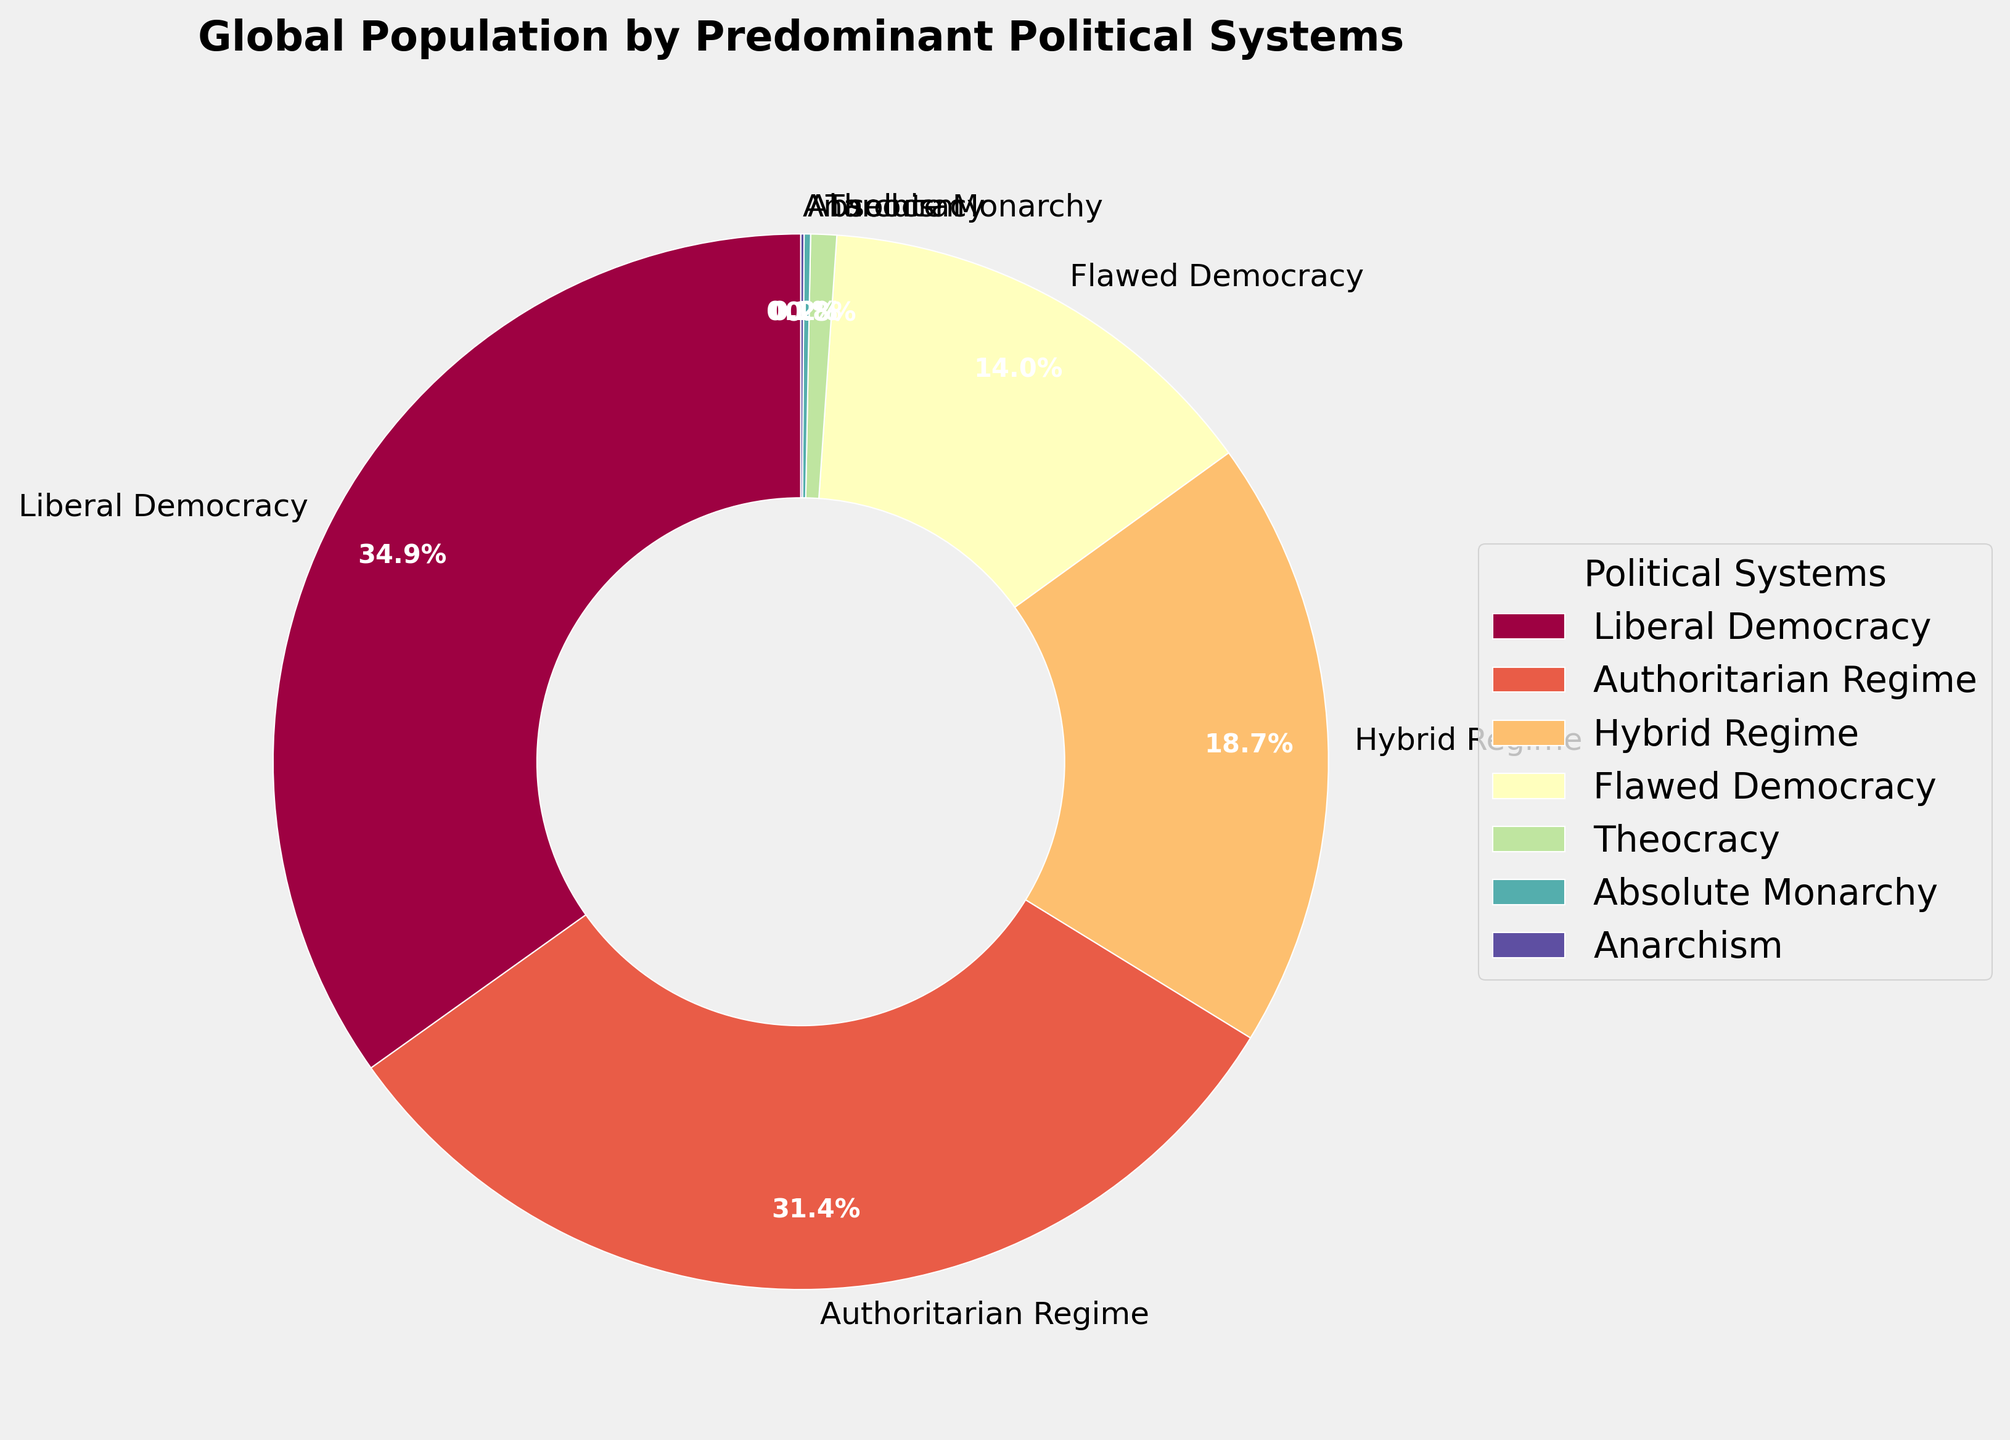Which political system has the largest share of the global population? The largest section of the pie chart will correspond to the political system with the highest population percentage. By checking the segments, we can identify the largest one. Liberal Democracy has the largest share.
Answer: Liberal Democracy What is the combined population percentage of Liberal Democracy and Authoritarian Regime? To find the combined population percentage, add the percentages of Liberal Democracy and Authoritarian Regime. Liberal Democracy is 35.2% and Authoritarian Regime is 31.7%. Sum these values: 35.2 + 31.7 = 66.9.
Answer: 66.9% Which political system has the smallest share of the global population? The smallest section of the pie chart will correspond to the political system with the lowest population percentage. By checking the segments, we can identify the smallest one. Anarchism has the smallest share.
Answer: Anarchism How much higher is the population percentage of Authoritarian Regime compared to Flawed Democracy? We can find the difference by subtracting the percentage of Flawed Democracy from the percentage of Authoritarian Regime. Authoritarian Regime is 31.7%, and Flawed Democracy is 14.1%. The difference is 31.7 - 14.1 = 17.6.
Answer: 17.6% What are the three political systems with the highest population percentages? By ranking the segments of the pie chart from highest to lowest, we can identify the top three. Liberal Democracy, Authoritarian Regime, and Hybrid Regime have the highest shares, respectively.
Answer: Liberal Democracy, Authoritarian Regime, Hybrid Regime What is the total population percentage represented by political systems other than Liberal Democracy? Subtract the percentage of Liberal Democracy from 100%. Liberal Democracy is 35.2%, so 100 - 35.2 = 64.8.
Answer: 64.8% Are there more people living under Authoritarian Regimes or Hybrid Regimes? By comparing the pie chart segments for Authoritarian Regime and Hybrid Regime, we can determine that Authoritarian Regime has a larger share than Hybrid Regime. Authoritarian Regime has 31.7%, while Hybrid Regime has 18.9%.
Answer: Authoritarian Regime How does the population percentage of Hybrid Regimes compare to that of Flawed Democracies? By comparing the pie chart segments for Hybrid Regime and Flawed Democracy, we can see that Hybrid Regime has a larger share than Flawed Democracy at 18.9% compared to 14.1%.
Answer: Hybrid Regime What is the percentage difference between Theocracy and Absolute Monarchy? Subtract the smaller percentage from the larger percentage. Theocracy is 0.8%, and Absolute Monarchy is 0.2%. The difference is 0.8 - 0.2 = 0.6.
Answer: 0.6% 